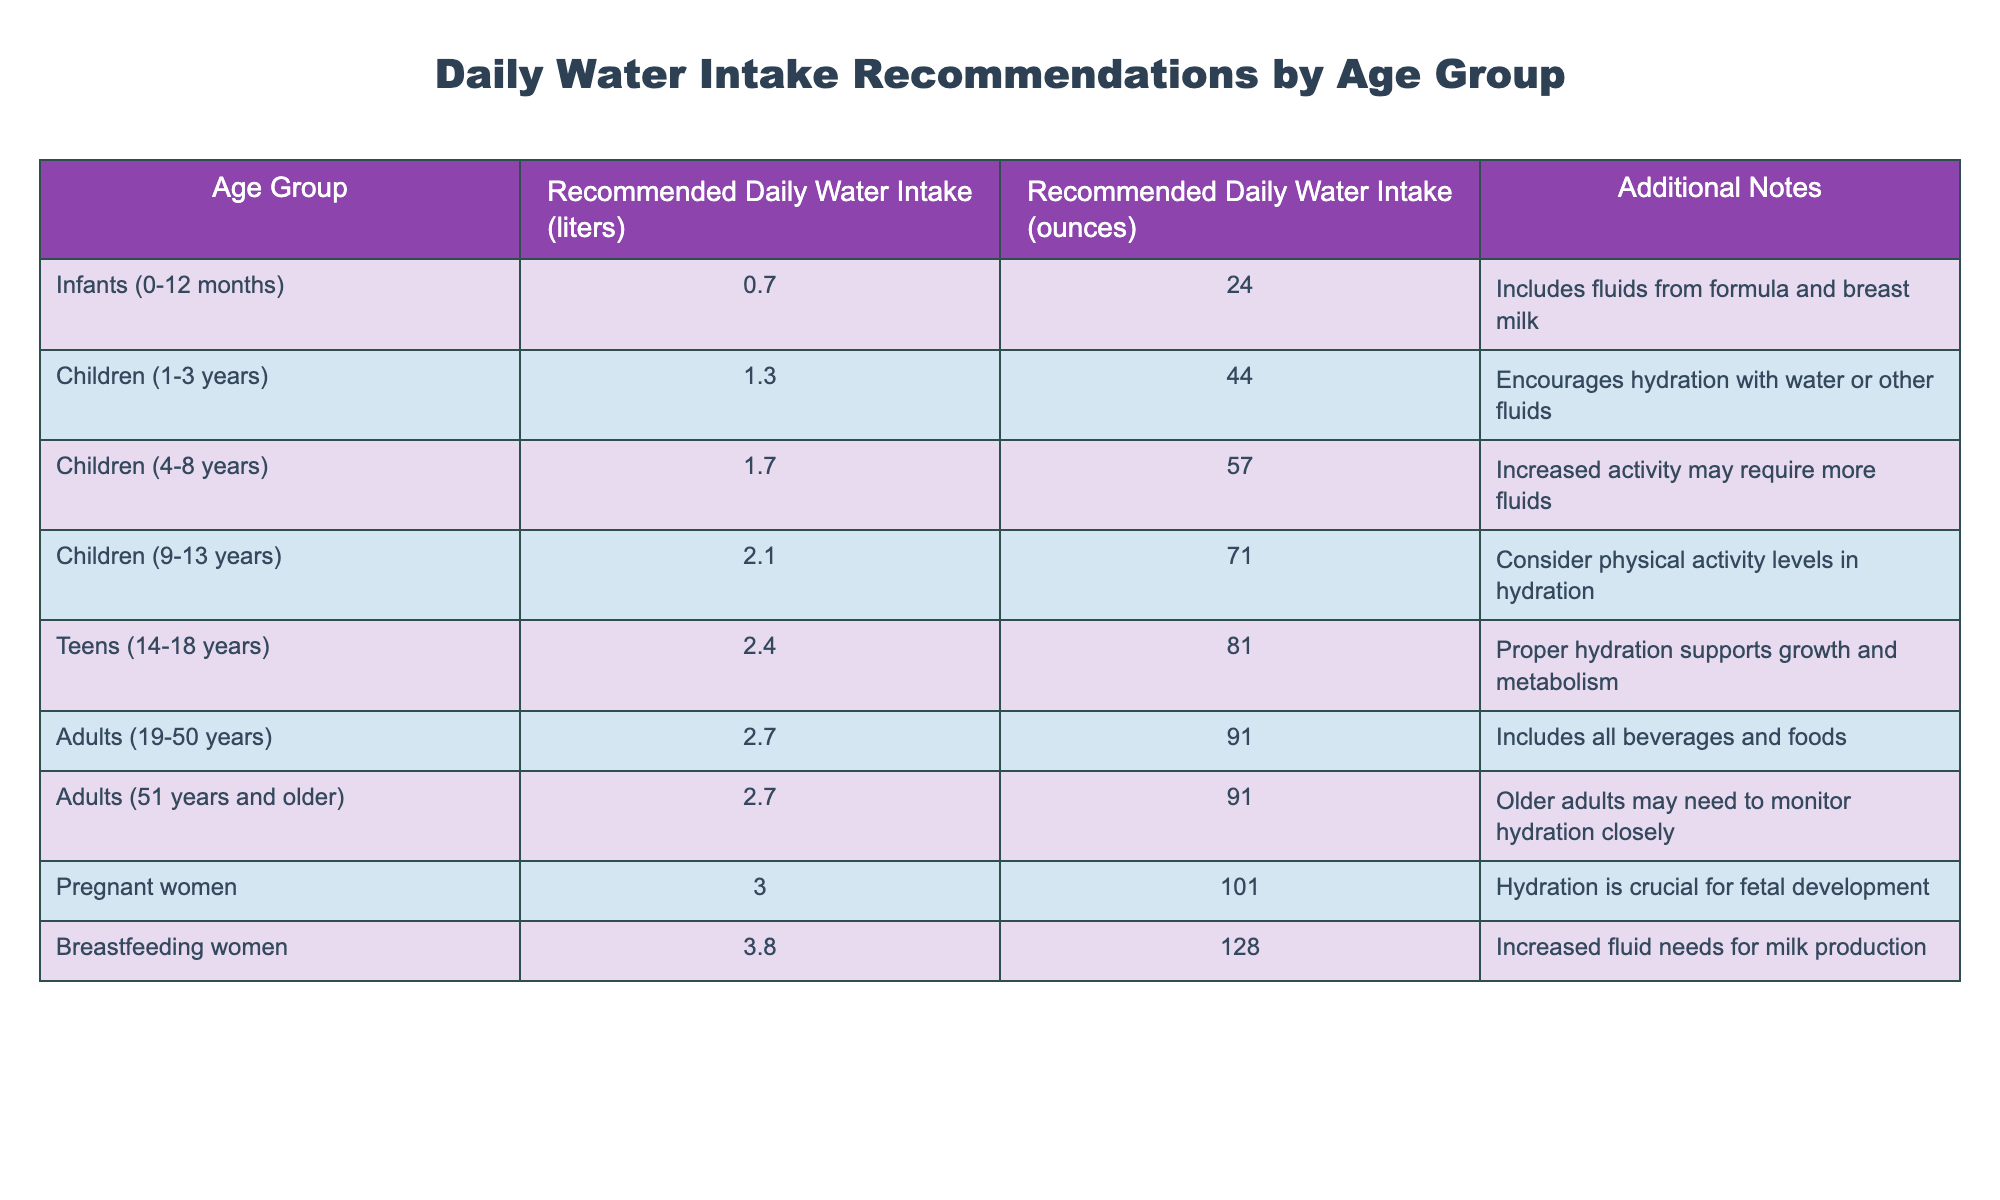What is the recommended daily water intake for teens aged 14-18 years? The table directly lists the recommended daily water intake for this age group as 2.4 liters.
Answer: 2.4 liters How much water should breastfeeding women drink daily? According to the table, breastfeeding women should drink 3.8 liters daily as indicated in the relevant row.
Answer: 3.8 liters Is the recommended daily water intake for adults aged 19-50 years different from those aged 51 years and older? The table shows that both age groups have the same recommended daily water intake of 2.7 liters, so the answer is no.
Answer: No What is the total recommended daily water intake for pregnant and breastfeeding women combined? For pregnant women, the intake is 3.0 liters, and for breastfeeding women, it is 3.8 liters. Adding these together gives 3.0 + 3.8 = 6.8 liters.
Answer: 6.8 liters Which age group has the highest recommended daily water intake and what is that amount? By examining the table, breastfeeding women require the highest daily intake of 3.8 liters, compared to others listed.
Answer: Breastfeeding women, 3.8 liters Do children aged 1-3 years require more or less water than those aged 4-8 years? The table indicates that children aged 1-3 years require 1.3 liters, while children aged 4-8 years require 1.7 liters. Thus, children aged 1-3 years require less water.
Answer: Less What is the combined recommended water intake for infants and children aged 1-3 years? Infants require 0.7 liters and children aged 1-3 years require 1.3 liters. Adding these amounts gives 0.7 + 1.3 = 2.0 liters.
Answer: 2.0 liters How much more water do pregnant women need compared to children aged 9-13 years? Pregnant women need 3.0 liters, while children aged 9-13 years need 2.1 liters. The difference is 3.0 - 2.1 = 0.9 liters more.
Answer: 0.9 liters Is it true that adults should drink the same amount of water as infants according to this table? This statement is false because adults need 2.7 liters while infants only need 0.7 liters, showing a significant difference.
Answer: No 